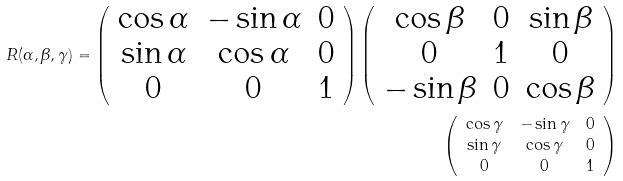Convert formula to latex. <formula><loc_0><loc_0><loc_500><loc_500>R ( \alpha , \beta , \gamma ) = \left ( \begin{array} { c c c } \cos \alpha & - \sin \alpha & 0 \\ \sin \alpha & \cos \alpha & 0 \\ 0 & 0 & 1 \end{array} \right ) \left ( \begin{array} { c c c } \cos \beta & 0 & \sin \beta \\ 0 & 1 & 0 \\ - \sin \beta & 0 & \cos \beta \end{array} \right ) \\ \left ( \begin{array} { c c c } \cos \gamma & - \sin \gamma & 0 \\ \sin \gamma & \cos \gamma & 0 \\ 0 & 0 & 1 \end{array} \right )</formula> 